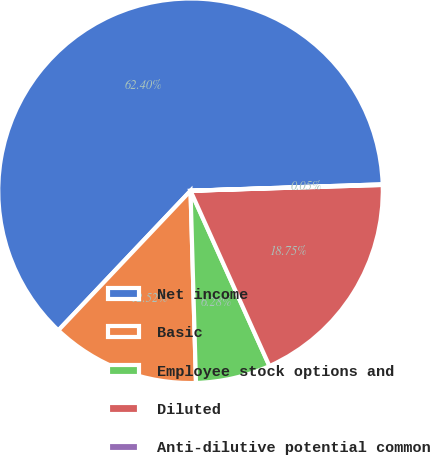<chart> <loc_0><loc_0><loc_500><loc_500><pie_chart><fcel>Net income<fcel>Basic<fcel>Employee stock options and<fcel>Diluted<fcel>Anti-dilutive potential common<nl><fcel>62.4%<fcel>12.52%<fcel>6.28%<fcel>18.75%<fcel>0.05%<nl></chart> 